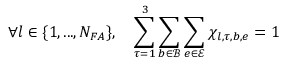<formula> <loc_0><loc_0><loc_500><loc_500>\forall l \in \{ 1 , \dots , N _ { F A } \} , \quad \sum _ { \tau = 1 } ^ { 3 } \sum _ { b \in \mathcal { B } } \sum _ { e \in \mathcal { E } } \chi _ { l , \tau , b , e } = 1</formula> 